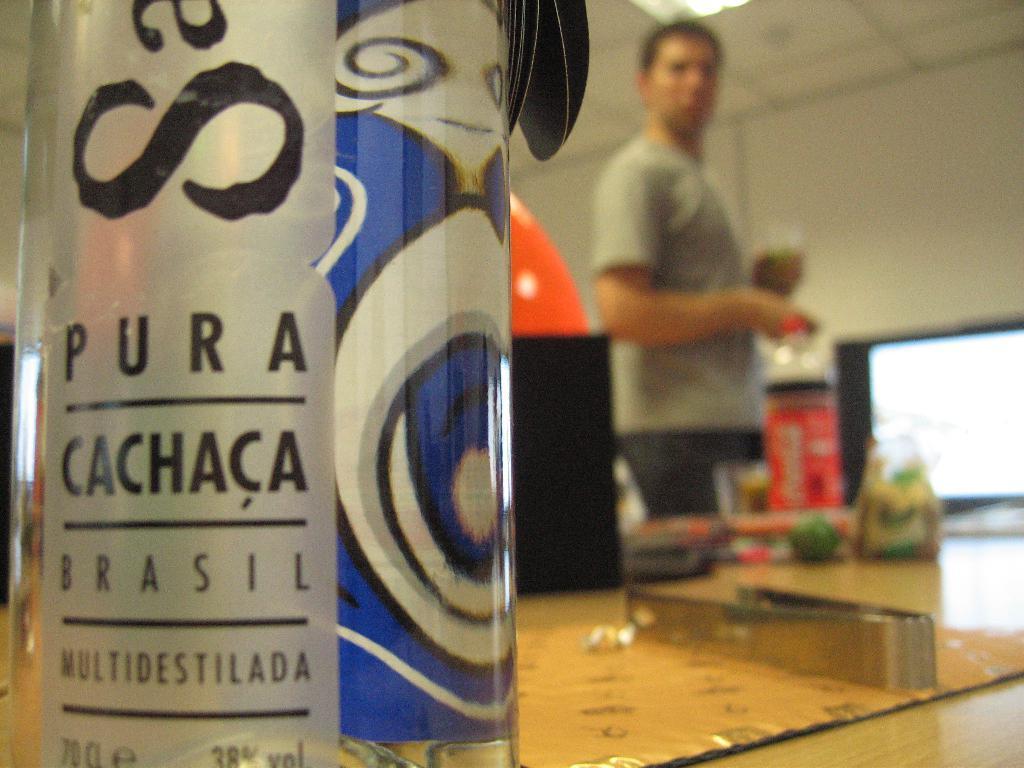Describe this image in one or two sentences. This picture is clicked inside the room and in front of the picture, we see a bottle in silver and blue color with some text written on it and the bottle is placed on the table. There are water bottle, plastic cover and a bowl is are placed on the table. Behind the table, we see man in grey color is standing and on the right corner of the picture, we see television and behind that, we see wall which is white in color. 